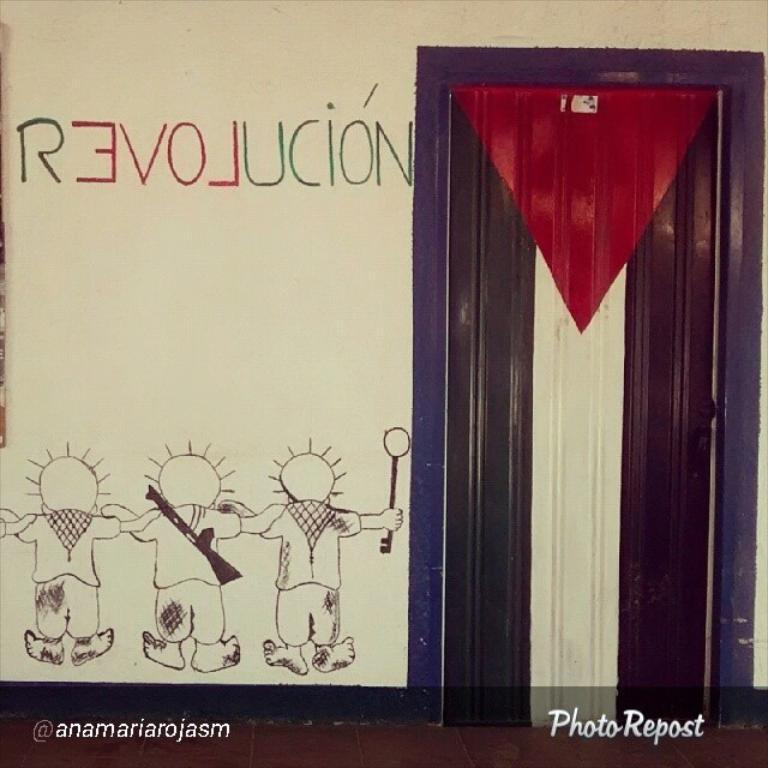What is featured in the image? There is a poster in the image. What elements are included on the poster? The poster includes a door and toys. Can you see an owl sitting on the door in the image? There is no owl present in the image. Is there a representative from the airline industry in the image? There is no representative from any industry present in the image; it only features a poster with a door and toys. 